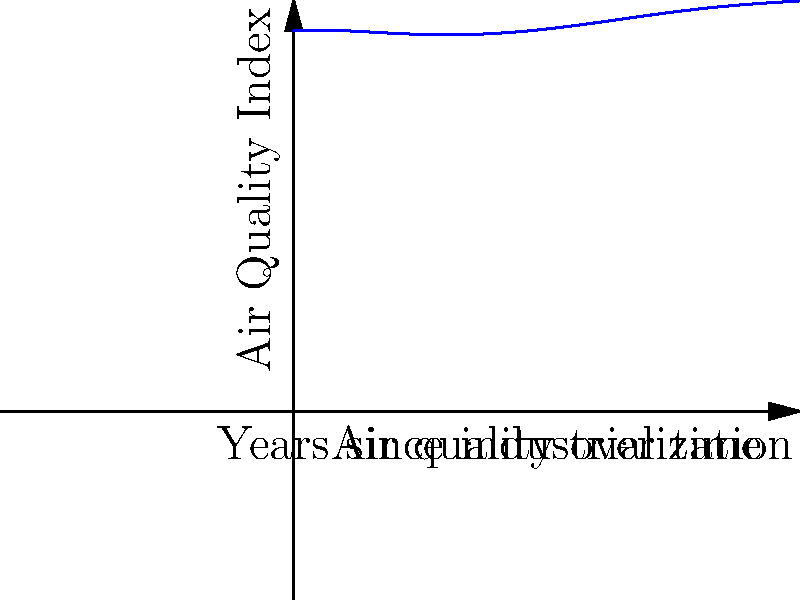As a documentary filmmaker examining the impact of industrial development on air quality, you've collected data that can be modeled by the quintic function $f(x) = 0.001x^5 - 0.03x^4 + 0.3x^3 - x^2 + 0.7x + 90$, where $x$ represents years since industrialization began and $f(x)$ represents the Air Quality Index (AQI). At approximately how many years after industrialization does the air quality reach its lowest point? To find the lowest point of air quality, we need to determine where the function reaches its minimum value within the relevant domain. This occurs where the derivative of the function equals zero and the second derivative is positive.

1) First, let's find the derivative of $f(x)$:
   $f'(x) = 0.005x^4 - 0.12x^3 + 0.9x^2 - 2x + 0.7$

2) Set the derivative equal to zero:
   $0.005x^4 - 0.12x^3 + 0.9x^2 - 2x + 0.7 = 0$

3) This equation is difficult to solve analytically. In practice, we would use numerical methods or graphing software to find the roots.

4) Using such methods, we find that the equation has roots at approximately x = 0.37, 2.76, 5.63, and 8.24.

5) To determine which of these is a minimum, we need to check the second derivative:
   $f''(x) = 0.02x^3 - 0.36x^2 + 1.8x - 2$

6) Evaluating $f''(x)$ at each point, we find that it's positive at x ≈ 5.63.

7) Therefore, the minimum occurs approximately 5.63 years after industrialization began.
Answer: Approximately 5.63 years 